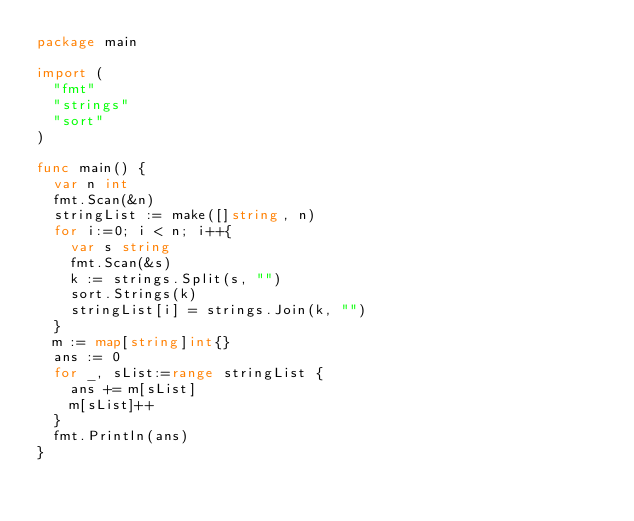<code> <loc_0><loc_0><loc_500><loc_500><_Go_>package main

import (
	"fmt"
	"strings"
	"sort"
)

func main() { 
	var n int
	fmt.Scan(&n)
	stringList := make([]string, n)
	for i:=0; i < n; i++{
		var s string
		fmt.Scan(&s)
		k := strings.Split(s, "")
		sort.Strings(k)
		stringList[i] = strings.Join(k, "")
	}
	m := map[string]int{}
	ans := 0
	for _, sList:=range stringList {
		ans += m[sList]
		m[sList]++
	}
	fmt.Println(ans)
}</code> 